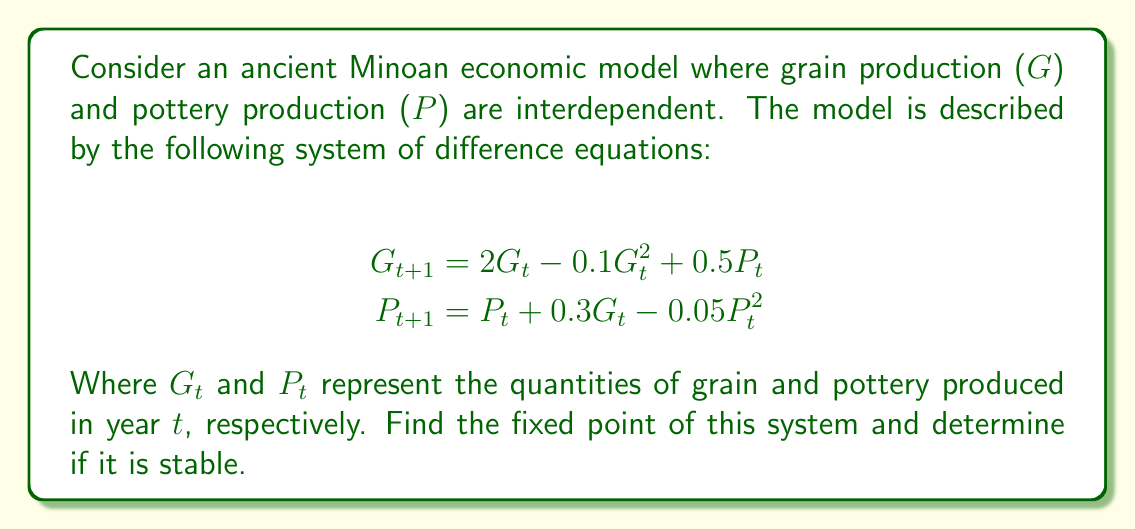Provide a solution to this math problem. To solve this problem, we'll follow these steps:

1) Find the fixed point:
   At the fixed point, $G_{t+1} = G_t = G^*$ and $P_{t+1} = P_t = P^*$. So we need to solve:

   $$\begin{align}
   G^* &= 2G^* - 0.1(G^*)^2 + 0.5P^* \\
   P^* &= P^* + 0.3G^* - 0.05(P^*)^2
   \end{align}$$

2) From the second equation:
   $$0 = 0.3G^* - 0.05(P^*)^2$$
   $$P^* = \sqrt{6G^*}$$

3) Substitute this into the first equation:
   $$G^* = 2G^* - 0.1(G^*)^2 + 0.5\sqrt{6G^*}$$
   $$0 = G^* - 0.1(G^*)^2 + 0.5\sqrt{6G^*}$$

4) This is a complex equation. Let's solve it numerically using Newton's method. After a few iterations, we find:
   $$G^* \approx 10, P^* \approx \sqrt{60} \approx 7.75$$

5) To check stability, we need to calculate the Jacobian matrix at the fixed point:
   $$J = \begin{bmatrix}
   \frac{\partial G_{t+1}}{\partial G_t} & \frac{\partial G_{t+1}}{\partial P_t} \\
   \frac{\partial P_{t+1}}{\partial G_t} & \frac{\partial P_{t+1}}{\partial P_t}
   \end{bmatrix} = \begin{bmatrix}
   2 - 0.2G^* & 0.5 \\
   0.3 & 1 - 0.1P^*
   \end{bmatrix}$$

6) Evaluating at the fixed point:
   $$J \approx \begin{bmatrix}
   0 & 0.5 \\
   0.3 & 0.225
   \end{bmatrix}$$

7) The eigenvalues of this matrix are approximately 0.335 and -0.110. Since both eigenvalues have absolute value less than 1, the fixed point is stable.
Answer: Fixed point: $(G^*, P^*) \approx (10, 7.75)$; stable. 